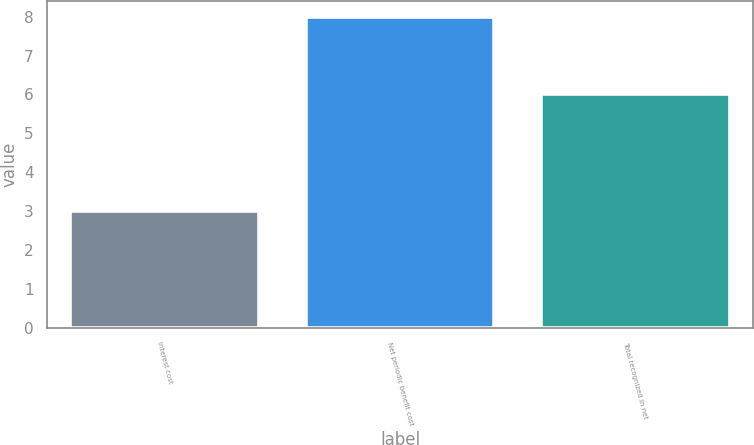Convert chart. <chart><loc_0><loc_0><loc_500><loc_500><bar_chart><fcel>Interest cost<fcel>Net periodic benefit cost<fcel>Total recognized in net<nl><fcel>3<fcel>8<fcel>6<nl></chart> 